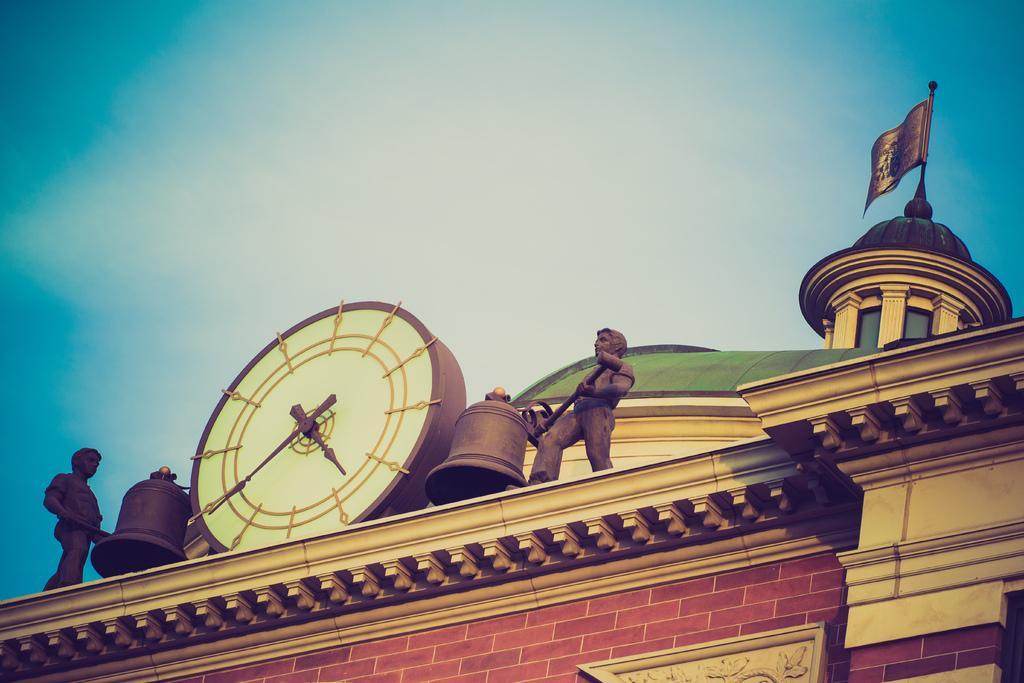How would you summarize this image in a sentence or two? We can see statues,in between these two statues we can see clock and bells. We can see wall,flag and sky. 